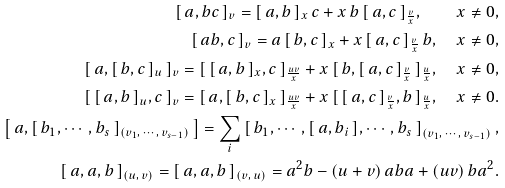Convert formula to latex. <formula><loc_0><loc_0><loc_500><loc_500>[ \, a , b c \, ] _ { v } = [ \, a , b \, ] _ { x } \, c + x \, b \, [ \, a , c \, ] _ { \frac { v } { x } } , \quad x \neq 0 , \\ [ \, a b , c \, ] _ { v } = a \, [ \, b , c \, ] _ { x } + x \, [ \, a , c \, ] _ { \frac { v } { x } } \, b , \quad x \neq 0 , \\ [ \, a , [ \, b , c \, ] _ { u } \, ] _ { v } = [ \, [ \, a , b \, ] _ { x } , c \, ] _ { \frac { u v } { x } } + x \, [ \, b , [ \, a , c \, ] _ { \frac { v } { x } } \, ] _ { \frac { u } { x } } , \quad x \neq 0 , \\ [ \, [ \, a , b \, ] _ { u } , c \, ] _ { v } = [ \, a , [ \, b , c \, ] _ { x } \, ] _ { \frac { u v } { x } } + x \, [ \, [ \, a , c \, ] _ { \frac { v } { x } } , b \, ] _ { \frac { u } { x } } , \quad x \neq 0 . \\ \left [ \, a , [ \, b _ { 1 } , \cdots , b _ { s } \, ] _ { ( v _ { 1 } , \, \cdots , \, v _ { s - 1 } ) } \, \right ] = \sum _ { i } \left [ \, b _ { 1 } , \cdots , [ \, a , b _ { i } \, ] , \cdots , b _ { s } \, \right ] _ { ( v _ { 1 } , \, \cdots , \, v _ { s - 1 } ) } , \\ [ \, a , a , b \, ] _ { ( u , \, v ) } = [ \, a , a , b \, ] _ { ( v , \, u ) } = a ^ { 2 } b - ( u + v ) \, a b a + ( u v ) \, b a ^ { 2 } .</formula> 